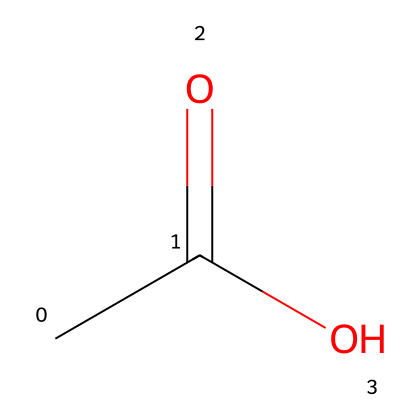What is the common name for the compound represented by this SMILES? The SMILES CC(=O)O indicates the presence of a carbon chain with a carboxylic acid functional group (-COOH). This structure corresponds to acetic acid, commonly known as vinegar.
Answer: vinegar How many carbon atoms are in the structure? The SMILES representation shows "CC", which indicates there are two carbon atoms in the compound; one is part of the carboxylic group, and the other is a methyl group.
Answer: two What type of functional group is present in this compound? The presence of "C(=O)O" indicates that this compound contains a carboxylic acid functional group, which is characterized by a carbon double-bonded to an oxygen and single-bonded to a hydroxyl group (-OH).
Answer: carboxylic acid How many hydrogen atoms are in the compound? The structure can be derived from the molecular formula C2H4O2. Counting the hydrogen atoms gives a total of four, as sourced from the methyl group and the hydroxyl group.
Answer: four What is the primary use of this compound in historical cleaning methods? Acetic acid, commonly known as vinegar, has been utilized for centuries in cleaning due to its ability to dissolve mineral deposits, kill bacteria, and remove odors, making it an effective household cleaner during historical times.
Answer: cleaning agent Is this compound aromatic or aliphatic? The structure does not contain any aromatic rings; it consists of a straight or branched chain of carbon atoms, thus it is categorized as aliphatic.
Answer: aliphatic 